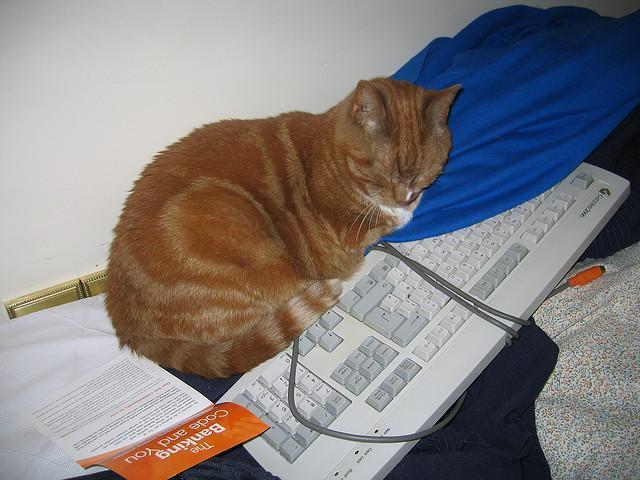How many keyboards in the picture?
Give a very brief answer. 1. 